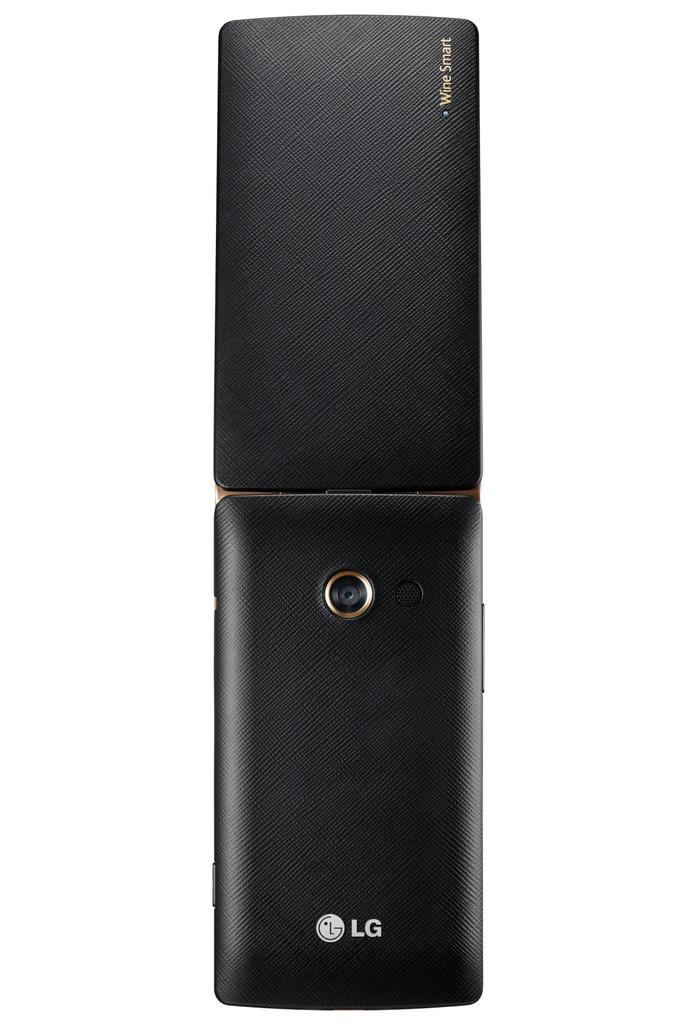<image>
Present a compact description of the photo's key features. A black LG phone sits on a white background. 